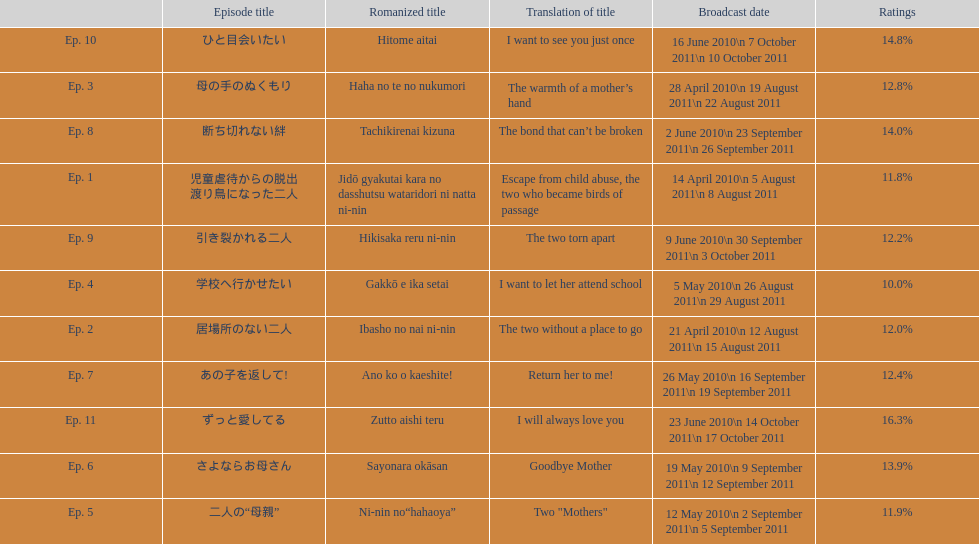What are all the episodes? Ep. 1, Ep. 2, Ep. 3, Ep. 4, Ep. 5, Ep. 6, Ep. 7, Ep. 8, Ep. 9, Ep. 10, Ep. 11. Of these, which ones have a rating of 14%? Ep. 8, Ep. 10. Of these, which one is not ep. 10? Ep. 8. 